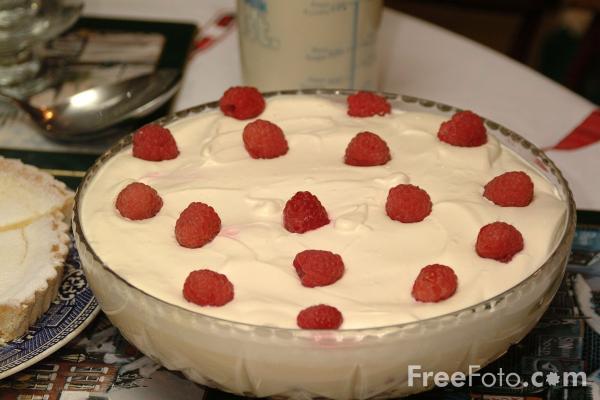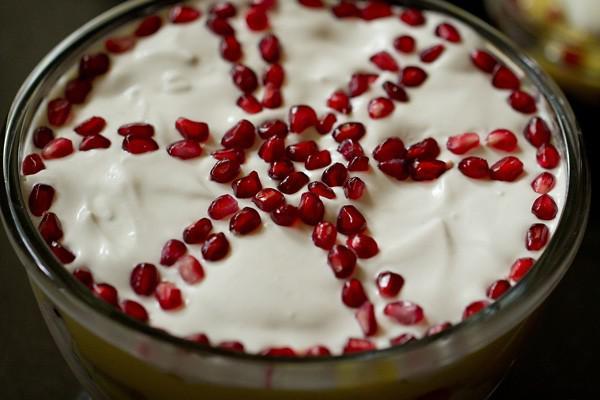The first image is the image on the left, the second image is the image on the right. Given the left and right images, does the statement "At least one dessert is garnished with leaves." hold true? Answer yes or no. No. 